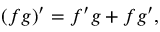<formula> <loc_0><loc_0><loc_500><loc_500>( f g ) ^ { \prime } = f ^ { \prime } g + f g ^ { \prime } ,</formula> 